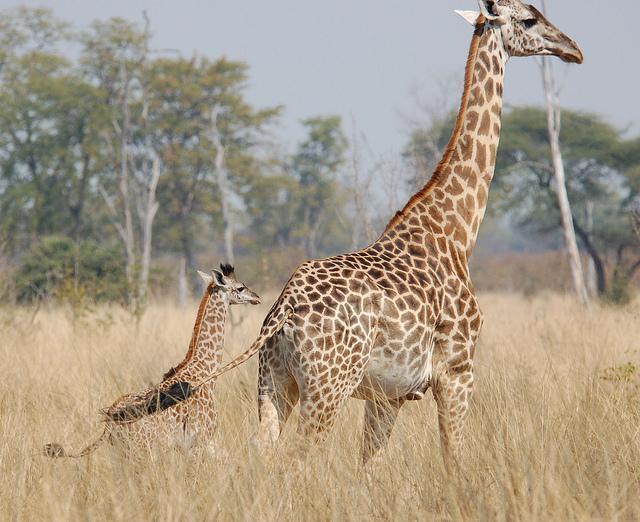How many giraffes are there?
Give a very brief answer. 2. How many giraffe are in the field?
Give a very brief answer. 2. How many giraffe are walking across the field?
Give a very brief answer. 2. How many giraffes can you see?
Give a very brief answer. 2. 